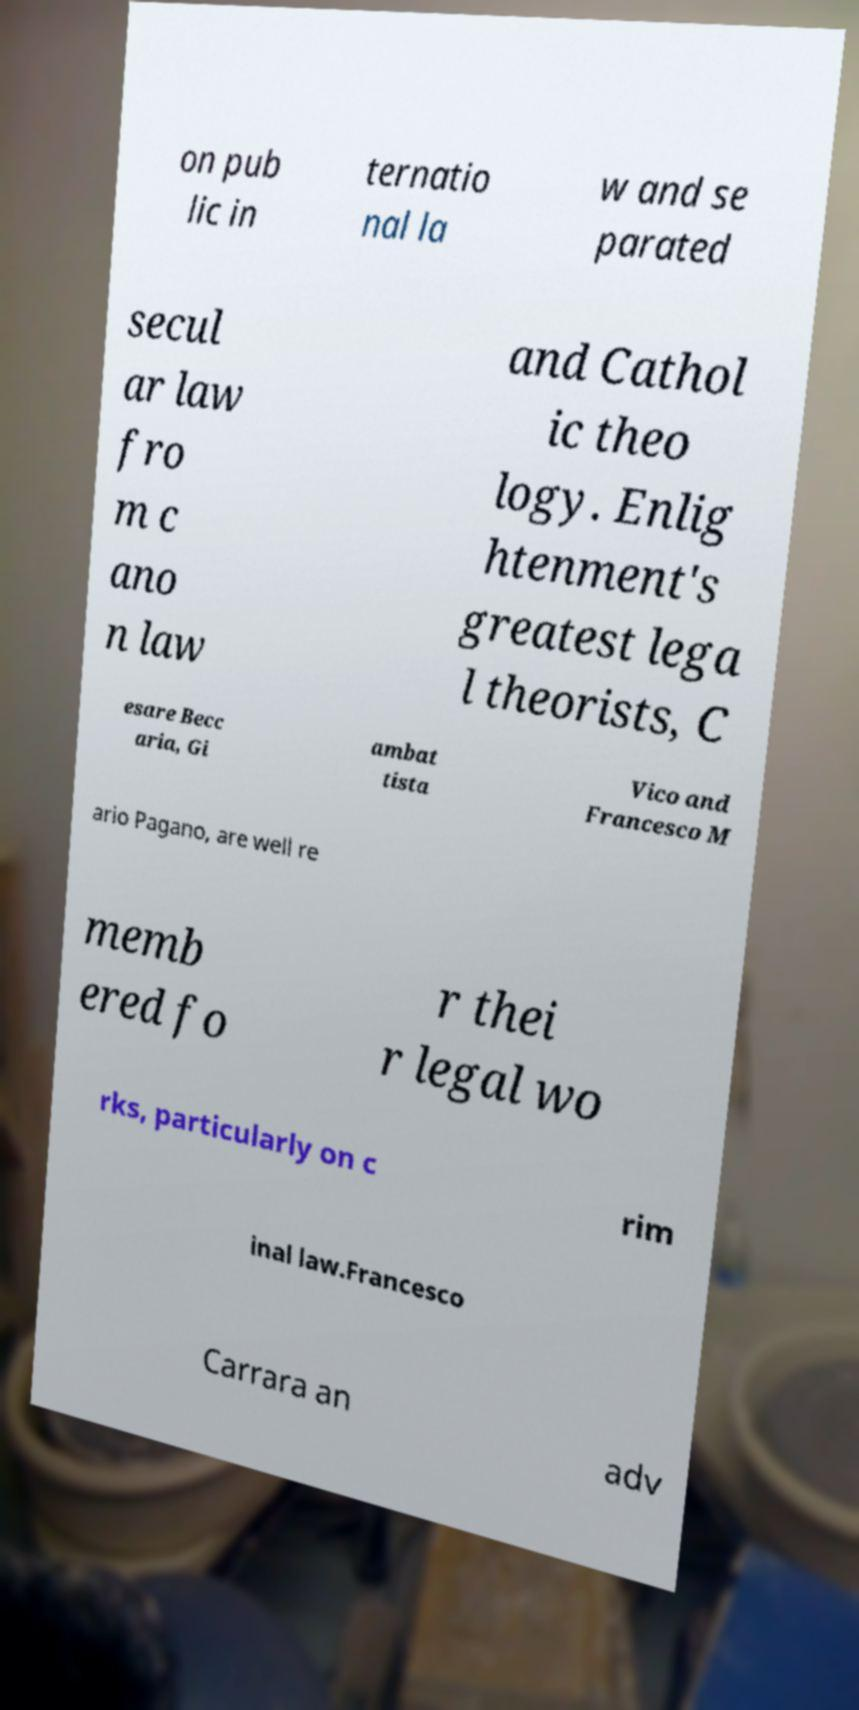Could you extract and type out the text from this image? on pub lic in ternatio nal la w and se parated secul ar law fro m c ano n law and Cathol ic theo logy. Enlig htenment's greatest lega l theorists, C esare Becc aria, Gi ambat tista Vico and Francesco M ario Pagano, are well re memb ered fo r thei r legal wo rks, particularly on c rim inal law.Francesco Carrara an adv 